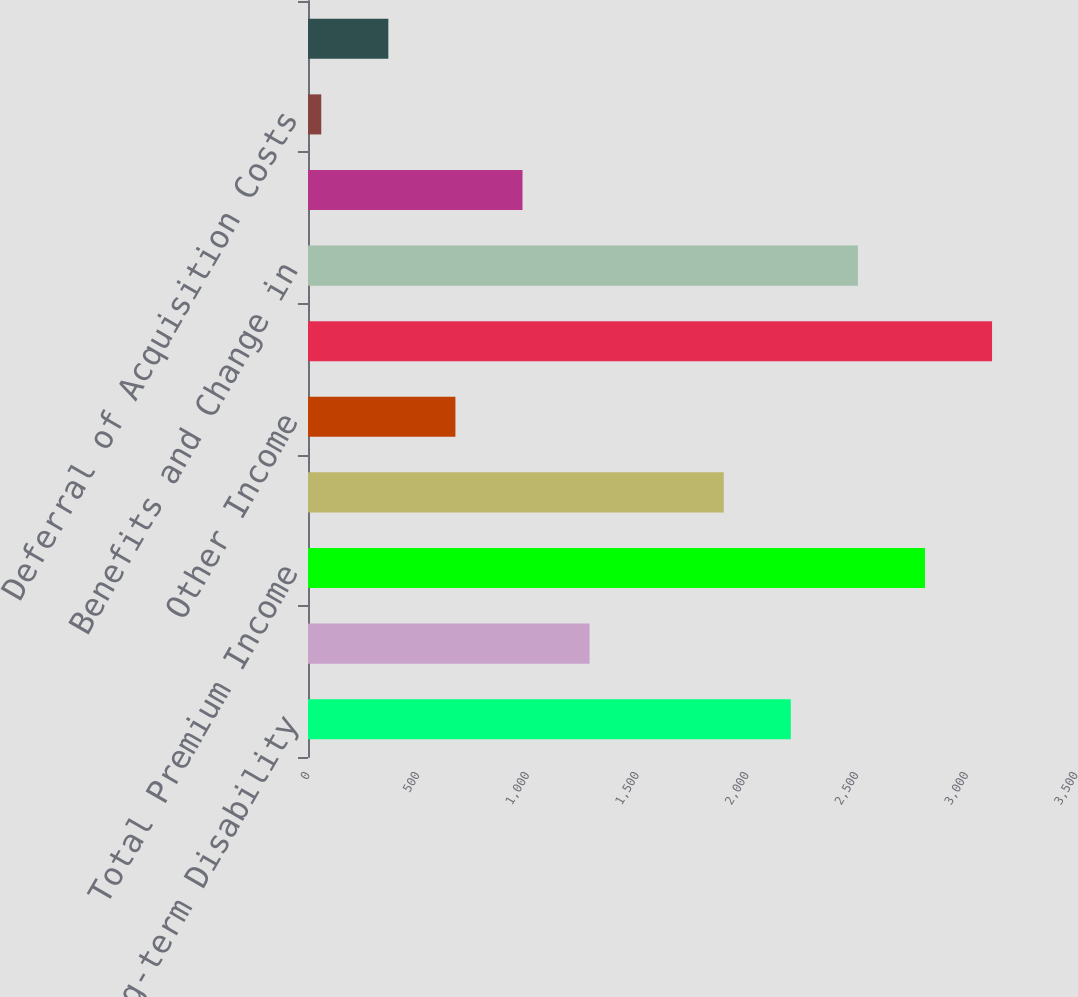Convert chart. <chart><loc_0><loc_0><loc_500><loc_500><bar_chart><fcel>Group Long-term Disability<fcel>Group Short-term Disability<fcel>Total Premium Income<fcel>Net Investment Income<fcel>Other Income<fcel>Total<fcel>Benefits and Change in<fcel>Commissions<fcel>Deferral of Acquisition Costs<fcel>Amortization of Deferred<nl><fcel>2200.37<fcel>1283.24<fcel>2811.79<fcel>1894.66<fcel>671.82<fcel>3117.5<fcel>2506.08<fcel>977.53<fcel>60.4<fcel>366.11<nl></chart> 